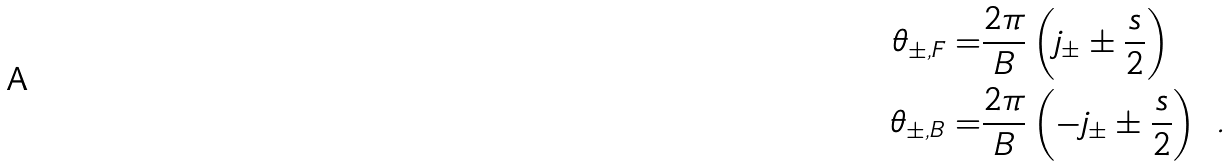Convert formula to latex. <formula><loc_0><loc_0><loc_500><loc_500>\theta _ { \pm , F } = & \frac { 2 \pi } { B } \left ( j _ { \pm } \pm \frac { s } { 2 } \right ) \\ \theta _ { \pm , B } = & \frac { 2 \pi } { B } \left ( - j _ { \pm } \pm \frac { s } { 2 } \right ) \ .</formula> 